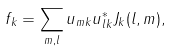Convert formula to latex. <formula><loc_0><loc_0><loc_500><loc_500>f _ { k } = \sum _ { m , l } u _ { m k } u _ { l k } ^ { * } J _ { k } ( l , m ) ,</formula> 